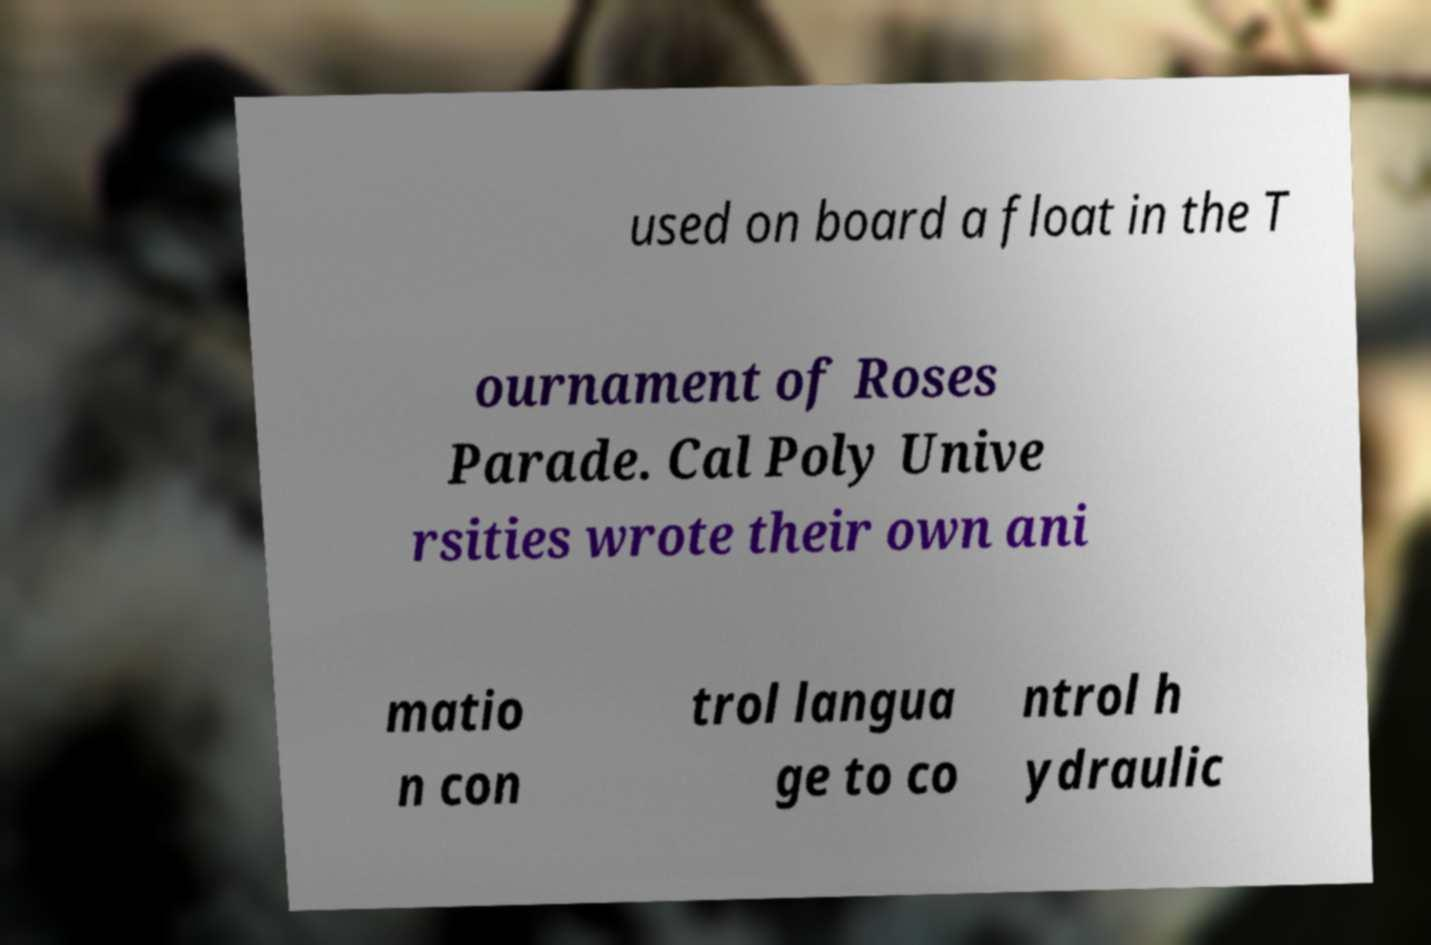Can you read and provide the text displayed in the image?This photo seems to have some interesting text. Can you extract and type it out for me? used on board a float in the T ournament of Roses Parade. Cal Poly Unive rsities wrote their own ani matio n con trol langua ge to co ntrol h ydraulic 